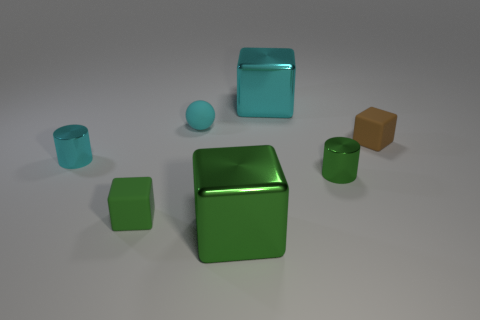Subtract all cyan cubes. Subtract all blue cylinders. How many cubes are left? 3 Add 1 big blue metal cylinders. How many objects exist? 8 Subtract all blocks. How many objects are left? 3 Add 7 small shiny objects. How many small shiny objects exist? 9 Subtract 1 cyan cylinders. How many objects are left? 6 Subtract all small cyan balls. Subtract all matte objects. How many objects are left? 3 Add 1 cyan cylinders. How many cyan cylinders are left? 2 